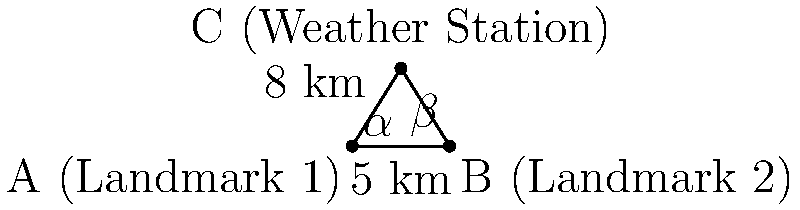Two known landmarks (A and B) are used to determine the location of a weather station (C) using triangulation. The distance between the landmarks is 5 km. From landmark A, the angle to the weather station ($\alpha$) is measured to be 58°, and from landmark B, the angle ($\beta$) is 52°. What is the distance between landmark A and the weather station? To solve this problem, we'll use the law of sines. Let's approach this step-by-step:

1) First, let's recall the law of sines:

   $$\frac{a}{\sin A} = \frac{b}{\sin B} = \frac{c}{\sin C}$$

   where $a$, $b$, and $c$ are the lengths of the sides opposite to angles $A$, $B$, and $C$ respectively.

2) In our triangle:
   - Side $c$ (between A and B) is 5 km
   - Angle $\alpha$ at A is 58°
   - Angle $\beta$ at B is 52°

3) We need to find the third angle of the triangle, let's call it $\gamma$:

   $$\gamma = 180° - (\alpha + \beta) = 180° - (58° + 52°) = 70°$$

4) Now we can use the law of sines to find the distance from A to C (let's call this distance $a$):

   $$\frac{a}{\sin \beta} = \frac{5}{\sin \gamma}$$

5) Rearranging to solve for $a$:

   $$a = \frac{5 \sin \beta}{\sin \gamma}$$

6) Plugging in the values:

   $$a = \frac{5 \sin 52°}{\sin 70°}$$

7) Calculating this:

   $$a \approx 8.00 \text{ km}$$

Therefore, the distance between landmark A and the weather station is approximately 8.00 km.
Answer: 8.00 km 